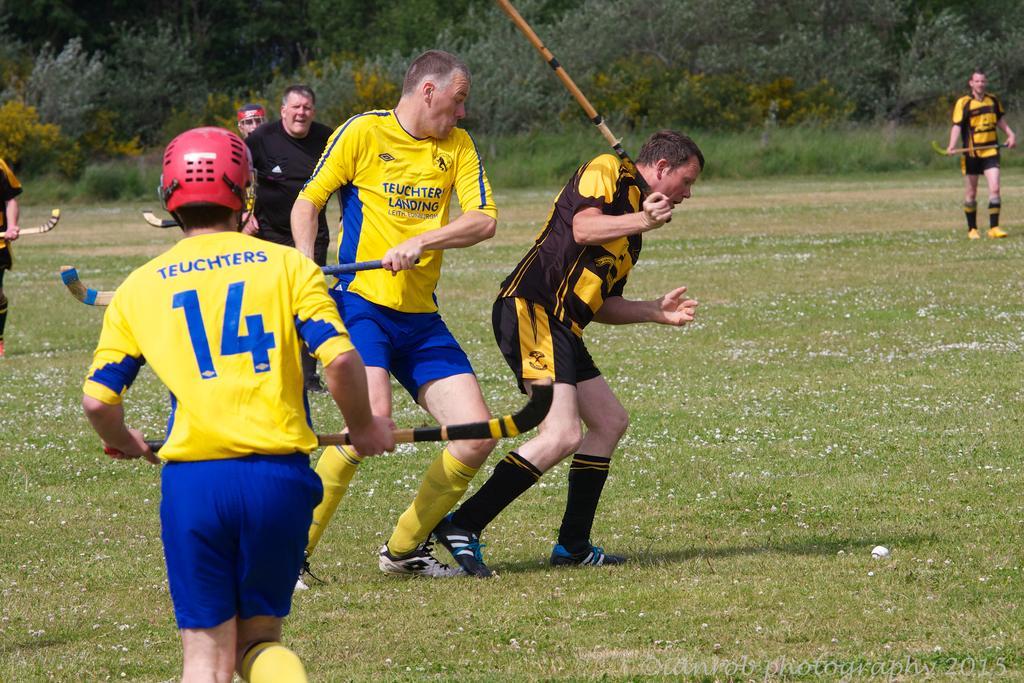What sport are the people playing in the foreground of the image? The people are playing hockey in the foreground of the image. What is the surface on which the hockey game is being played? The hockey game is taking place on a grassland. What can be seen in the background of the image? There are other people and greenery visible in the background of the image. What is the purpose of the oranges in the image? There are no oranges present in the image, so there is no purpose for them. 